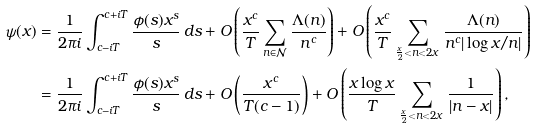Convert formula to latex. <formula><loc_0><loc_0><loc_500><loc_500>\psi ( x ) & = \frac { 1 } { 2 \pi i } \int _ { c - i T } ^ { c + i T } \frac { \phi ( s ) x ^ { s } } { s } \, d s + O \left ( \frac { x ^ { c } } { T } \sum _ { n \in \mathcal { N } } \frac { \Lambda ( n ) } { n ^ { c } } \right ) + O \left ( \frac { x ^ { c } } { T } \sum _ { \frac { x } { 2 } < n < 2 x } \frac { \Lambda ( n ) } { n ^ { c } | \log x / n | } \right ) \\ & = \frac { 1 } { 2 \pi i } \int _ { c - i T } ^ { c + i T } \frac { \phi ( s ) x ^ { s } } { s } \, d s + O \left ( \frac { x ^ { c } } { T ( c - 1 ) } \right ) + O \left ( \frac { x \log x } { T } \sum _ { \frac { x } { 2 } < n < 2 x } \frac { 1 } { | n - x | } \right ) ,</formula> 